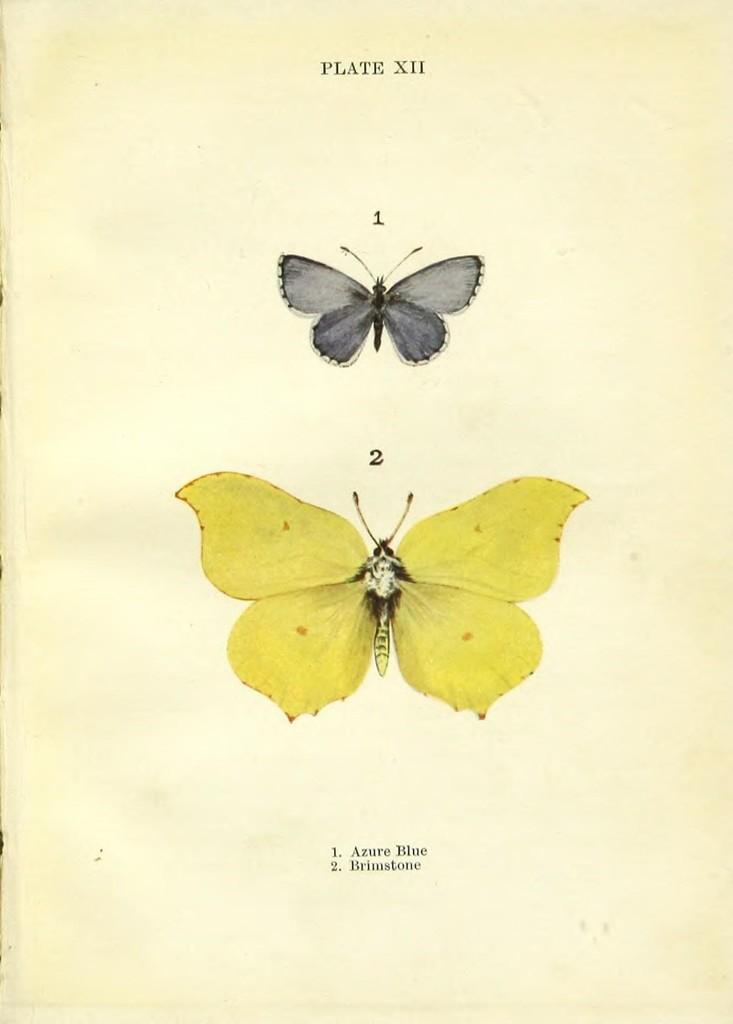What is the medium of the image? The image might be a painting on paper. How many butterflies are present in the image? There are two butterflies in the image. What are the colors of the butterflies? One butterfly is yellow, and the other is black. What type of board is being offered by the butterflies in the image? There is no board being offered by the butterflies in the image; they are simply depicted as two butterflies of different colors. What kind of connection can be seen between the butterflies in the image? There is no specific connection between the butterflies in the image; they are simply two butterflies of different colors. 